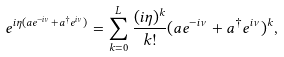Convert formula to latex. <formula><loc_0><loc_0><loc_500><loc_500>e ^ { i \eta ( a e ^ { - i \nu } + a ^ { \dagger } e ^ { i \nu } ) } = \sum _ { k = 0 } ^ { L } \frac { ( i \eta ) ^ { k } } { k ! } ( a e ^ { - i \nu } + a ^ { \dagger } e ^ { i \nu } ) ^ { k } ,</formula> 